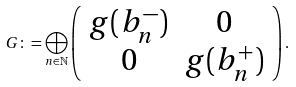<formula> <loc_0><loc_0><loc_500><loc_500>G \colon = \bigoplus _ { n \in \mathbb { N } } \left ( \begin{array} { c c } g ( b _ { n } ^ { - } ) & 0 \\ 0 & g ( b _ { n } ^ { + } ) \end{array} \right ) .</formula> 